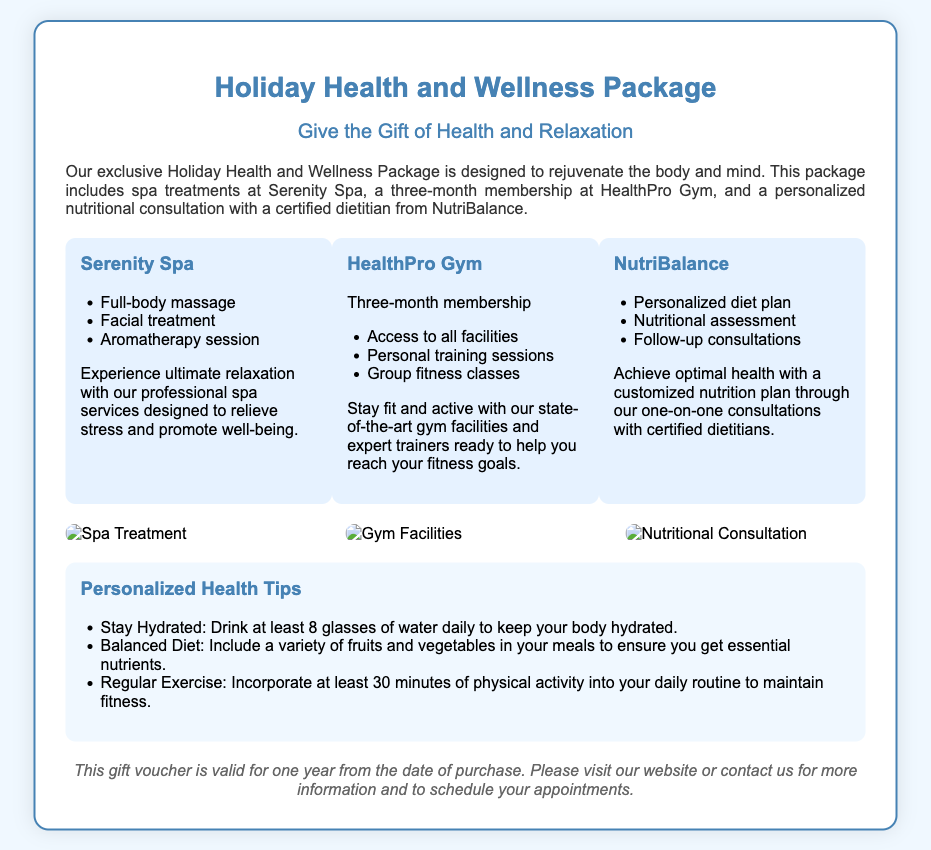what is included in the Holiday Health and Wellness Package? The document lists spa treatments, gym membership, and nutritional consultation as components of the package.
Answer: spa treatments, gym membership, and nutritional consultation how long is the gym membership valid for? The document states that the gym membership is valid for three months.
Answer: three months what treatments are offered at Serenity Spa? The document details three specific treatments offered at Serenity Spa: full-body massage, facial treatment, and aromatherapy session.
Answer: full-body massage, facial treatment, aromatherapy session who provides the nutritional consultation? The document specifies that a certified dietitian from NutriBalance will provide the consultation.
Answer: NutriBalance how many health tips are provided in the voucher? The document lists three personalized health tips.
Answer: three what color is used for the header text in the voucher? The text color in the header section of the voucher is specified as #4682b4.
Answer: #4682b4 is there any imagery included in the document? The document mentions visuals showcasing a spa treatment, gym facilities, and nutritional consultation, confirming the inclusion of images.
Answer: yes how long is the gift voucher valid? The document states that the gift voucher is valid for one year from the date of purchase.
Answer: one year what type of document is this? The document is identified as a gift voucher.
Answer: gift voucher 